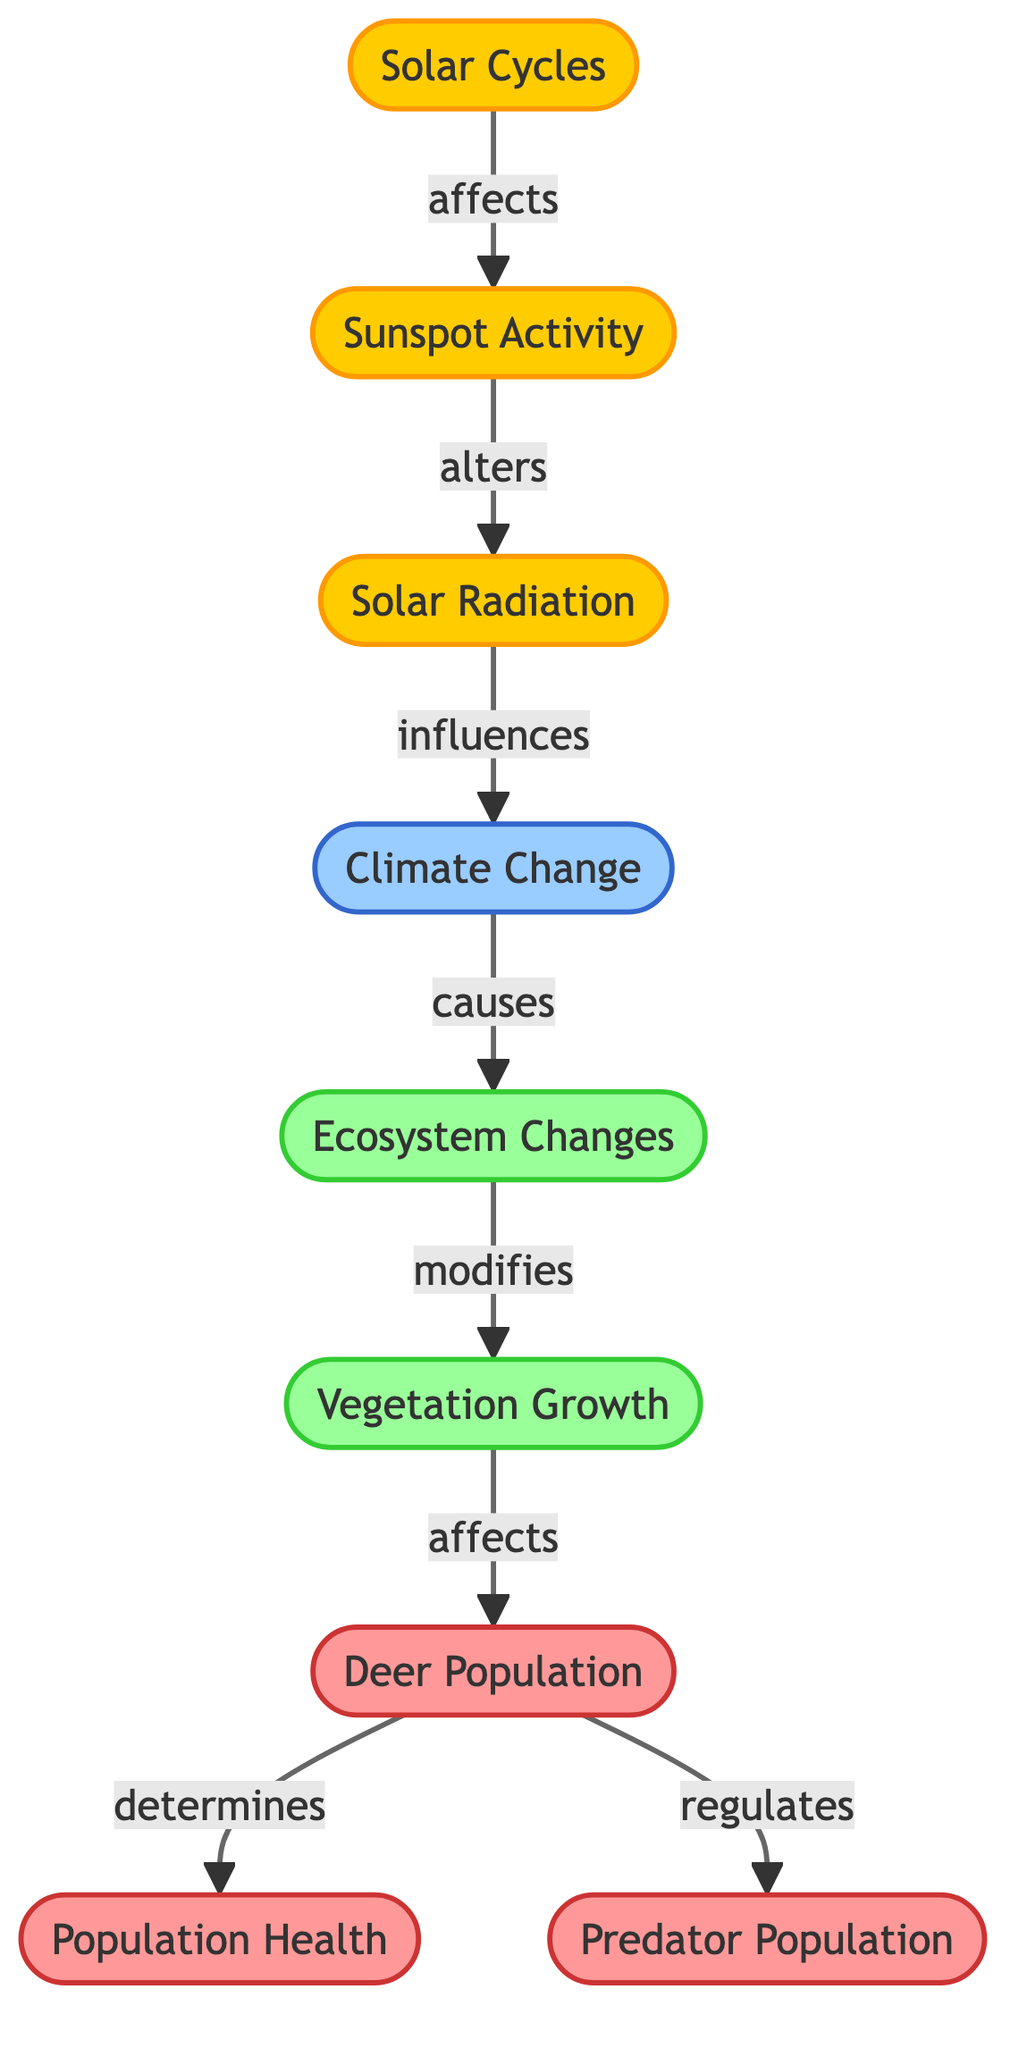What is the central theme of the diagram? The central theme revolves around the correlation between solar cycles and various ecological factors, including deer population dynamics, thereby establishing the relationship and impact of solar activities on ecosystems.
Answer: Correlation between solar cycles and deer population dynamics How many main nodes are present in the diagram? By counting the distinct nodes in the diagram, there are a total of eight main nodes representing the key concepts related to solar cycles and deer populations.
Answer: Eight What does solar cycles affect directly in the diagram? According to the diagram, solar cycles affect sunspot activity directly, establishing a starting point for the chain of influences represented.
Answer: Sunspot activity Which nodes are influenced by vegetation growth? The diagram shows that vegetation growth influences the deer population as well as their population health and indirectly affects predator population. Thus, it's clear that both deer population and population health are influenced.
Answer: Deer population, population health What happens to the deer population as a result of ecosystem changes? The diagram indicates that ecosystem changes modify vegetation growth, which in turn affects deer population, demonstrating a cascading relationship from ecosystem health to deer dynamics.
Answer: Deer population decreases/increases (context needed) How is the predator population regulated according to the diagram? The diagram illustrates that the deer population regulates the predator population, indicating that changes in deer numbers directly influence predator dynamics within the ecosystem.
Answer: Deer population Which factor modifies vegetation growth in the diagram? The diagram indicates that ecosystem changes are the factors that modify vegetation growth, establishing a link between broader ecological dynamics and specific vegetation outcomes.
Answer: Ecosystem changes What is necessary for the population health of deer according to the diagram? Based on the diagram, the health of deer populations is determined by the overall status of the deer population itself, highlighting the interconnectedness of population dynamics with health outcomes.
Answer: Deer population What element comes after solar radiation in the flow of the diagram? The flow of the diagram indicates that after solar radiation, climate change is the subsequent element, illustrating the influence of solar activity on broader climatic conditions.
Answer: Climate change 